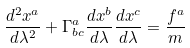Convert formula to latex. <formula><loc_0><loc_0><loc_500><loc_500>\frac { d ^ { 2 } x ^ { a } } { d \lambda ^ { 2 } } + \Gamma ^ { a } _ { b c } \frac { d x ^ { b } } { d \lambda } \frac { d x ^ { c } } { d \lambda } = \frac { f ^ { a } } { m }</formula> 